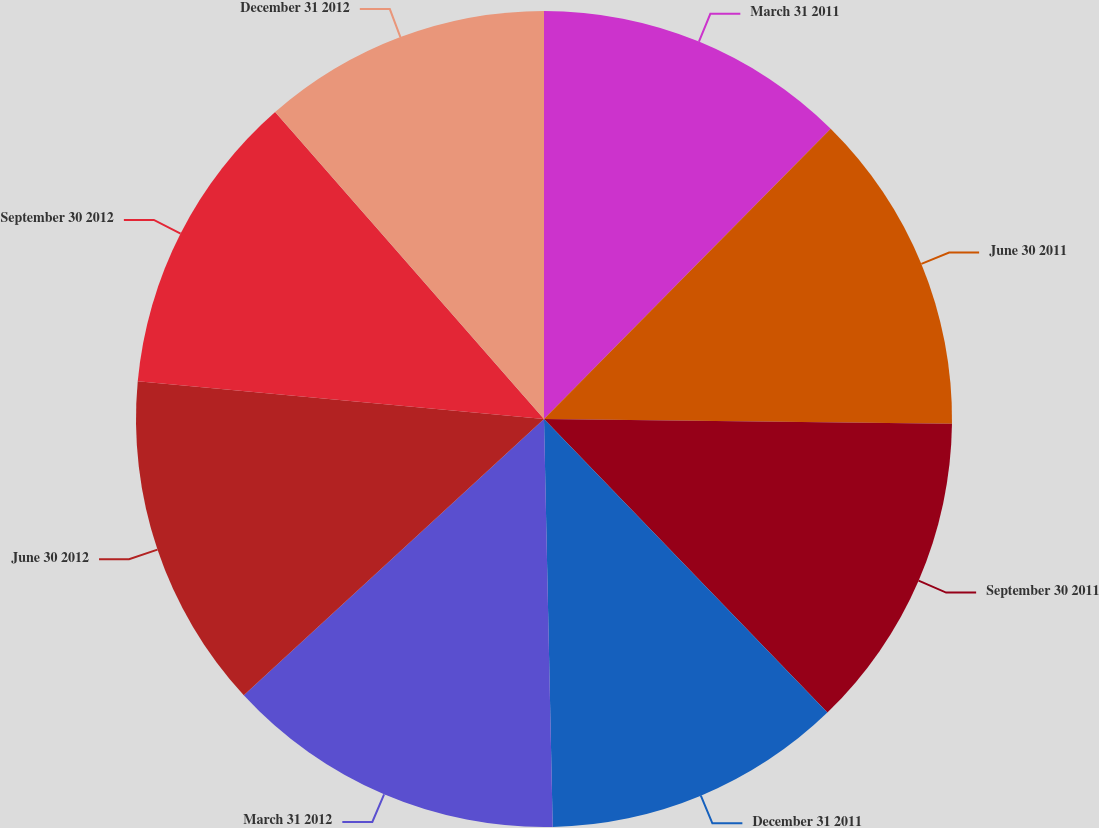Convert chart. <chart><loc_0><loc_0><loc_500><loc_500><pie_chart><fcel>March 31 2011<fcel>June 30 2011<fcel>September 30 2011<fcel>December 31 2011<fcel>March 31 2012<fcel>June 30 2012<fcel>September 30 2012<fcel>December 31 2012<nl><fcel>12.4%<fcel>12.79%<fcel>12.59%<fcel>11.88%<fcel>13.5%<fcel>13.31%<fcel>12.08%<fcel>11.45%<nl></chart> 